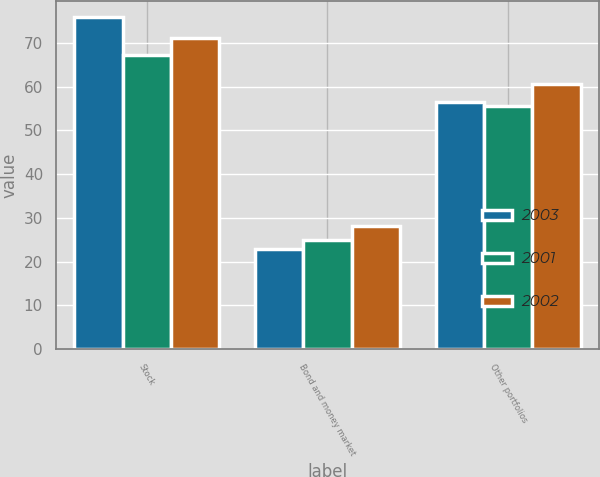Convert chart. <chart><loc_0><loc_0><loc_500><loc_500><stacked_bar_chart><ecel><fcel>Stock<fcel>Bond and money market<fcel>Other portfolios<nl><fcel>2003<fcel>75.8<fcel>22.9<fcel>56.5<nl><fcel>2001<fcel>67.1<fcel>25<fcel>55.5<nl><fcel>2002<fcel>71.2<fcel>28.2<fcel>60.5<nl></chart> 